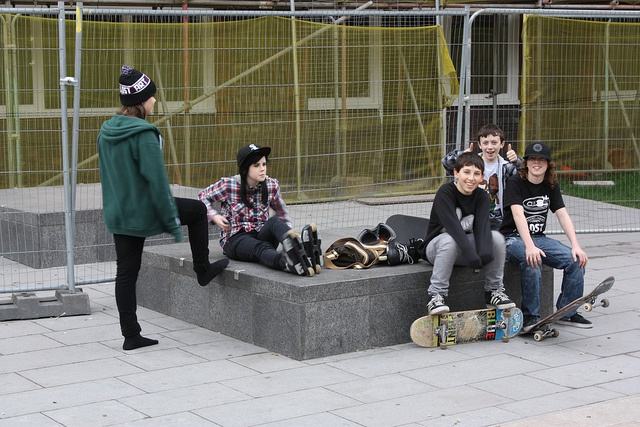Describe the objects in this image and their specific colors. I can see people in black, teal, gray, and darkgray tones, people in black, gray, darkgray, and lightgray tones, people in black, gray, lightgray, and darkgray tones, people in black, gray, and darkgray tones, and skateboard in black, darkgray, gray, and tan tones in this image. 